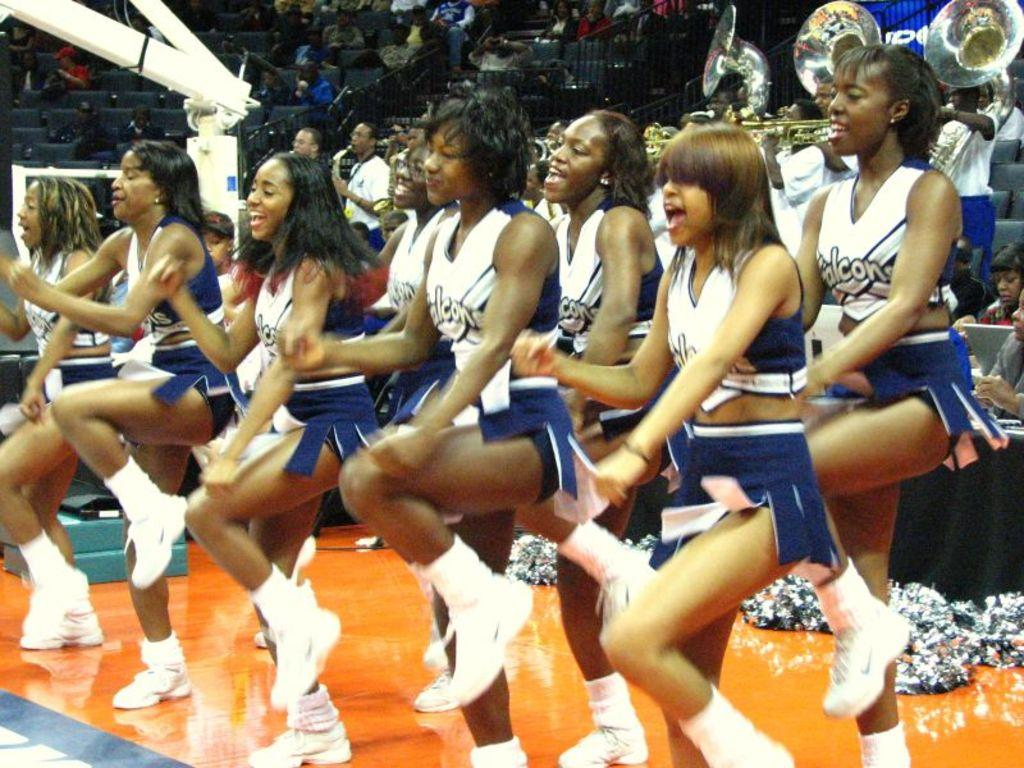Provide a one-sentence caption for the provided image. The cheer leaders are doing their best to cheer on the Falcons. 